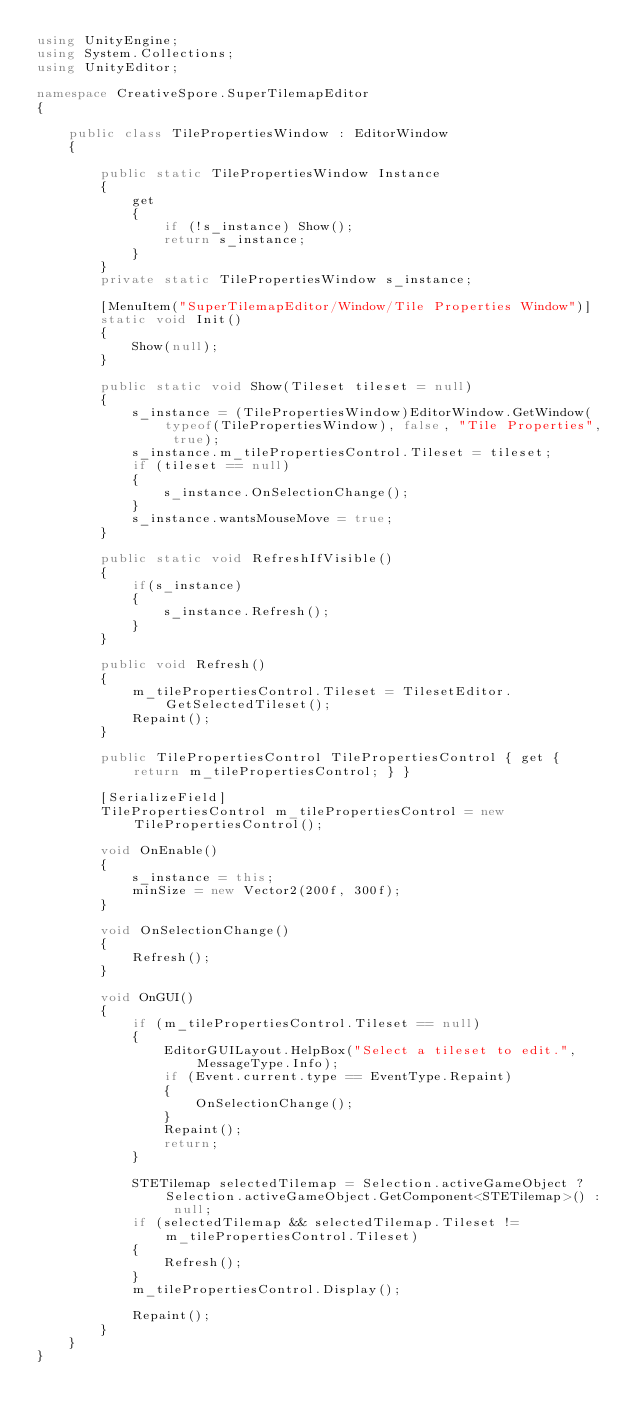<code> <loc_0><loc_0><loc_500><loc_500><_C#_>using UnityEngine;
using System.Collections;
using UnityEditor;

namespace CreativeSpore.SuperTilemapEditor
{

    public class TilePropertiesWindow : EditorWindow
    {

        public static TilePropertiesWindow Instance
        {
            get 
            {
                if (!s_instance) Show();
                return s_instance; 
            }
        }
        private static TilePropertiesWindow s_instance;

        [MenuItem("SuperTilemapEditor/Window/Tile Properties Window")]
        static void Init()
        {
            Show(null);
        }

        public static void Show(Tileset tileset = null)
        {
            s_instance = (TilePropertiesWindow)EditorWindow.GetWindow(typeof(TilePropertiesWindow), false, "Tile Properties", true);            
            s_instance.m_tilePropertiesControl.Tileset = tileset;
            if (tileset == null)
            {
                s_instance.OnSelectionChange();
            }
            s_instance.wantsMouseMove = true;
        }

        public static void RefreshIfVisible()
        {
            if(s_instance)
            {
                s_instance.Refresh();
            }
        }

        public void Refresh()
        {
            m_tilePropertiesControl.Tileset = TilesetEditor.GetSelectedTileset();            
            Repaint();
        }

        public TilePropertiesControl TilePropertiesControl { get { return m_tilePropertiesControl; } }

        [SerializeField]
        TilePropertiesControl m_tilePropertiesControl = new TilePropertiesControl();

        void OnEnable()
        {
            s_instance = this;
            minSize = new Vector2(200f, 300f);
        }

        void OnSelectionChange()
        {
            Refresh();
        }

        void OnGUI()
        {
            if (m_tilePropertiesControl.Tileset == null)
            {
                EditorGUILayout.HelpBox("Select a tileset to edit.", MessageType.Info);
                if (Event.current.type == EventType.Repaint)
                {
                    OnSelectionChange();
                }
                Repaint();
                return;
            }

            STETilemap selectedTilemap = Selection.activeGameObject ? Selection.activeGameObject.GetComponent<STETilemap>() : null;
            if (selectedTilemap && selectedTilemap.Tileset != m_tilePropertiesControl.Tileset)
            {
                Refresh();
            }
            m_tilePropertiesControl.Display();

            Repaint();
        }
    }
}
</code> 